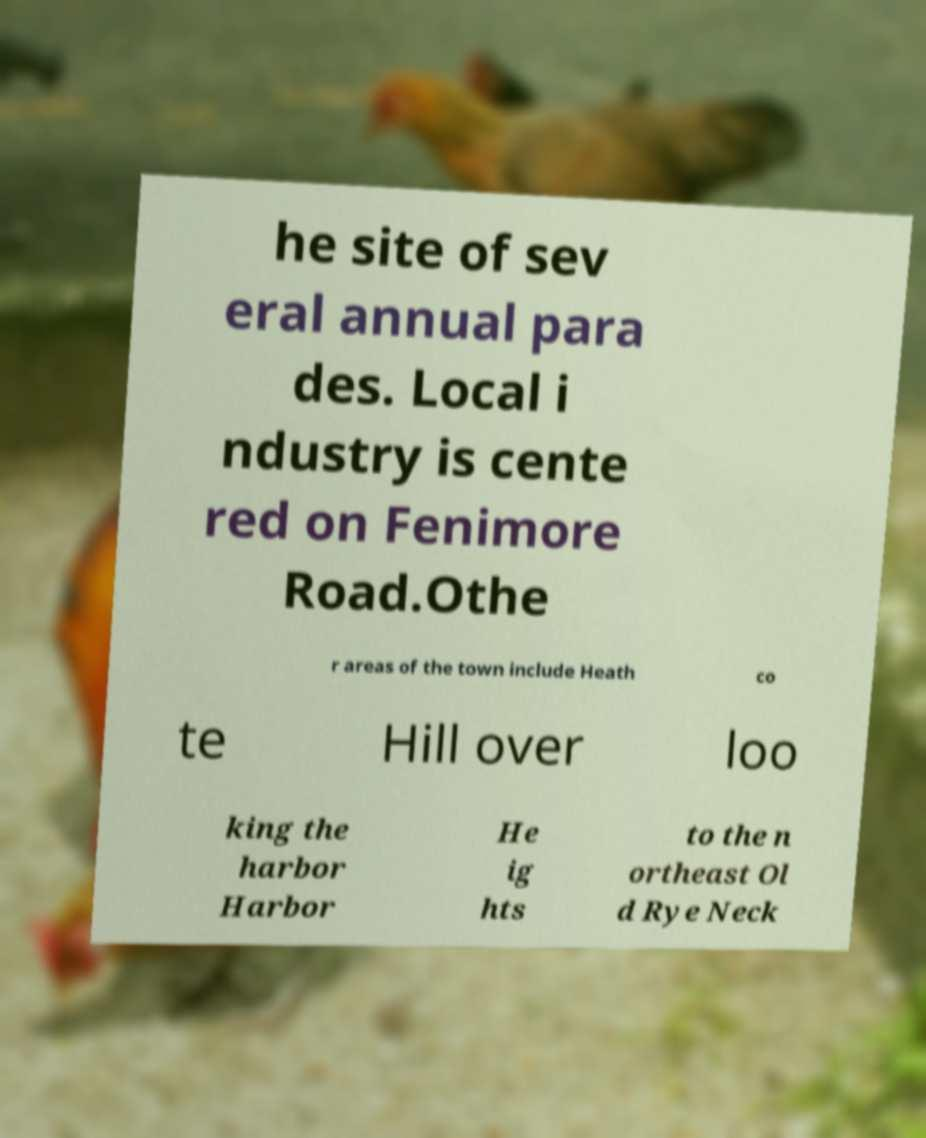There's text embedded in this image that I need extracted. Can you transcribe it verbatim? he site of sev eral annual para des. Local i ndustry is cente red on Fenimore Road.Othe r areas of the town include Heath co te Hill over loo king the harbor Harbor He ig hts to the n ortheast Ol d Rye Neck 